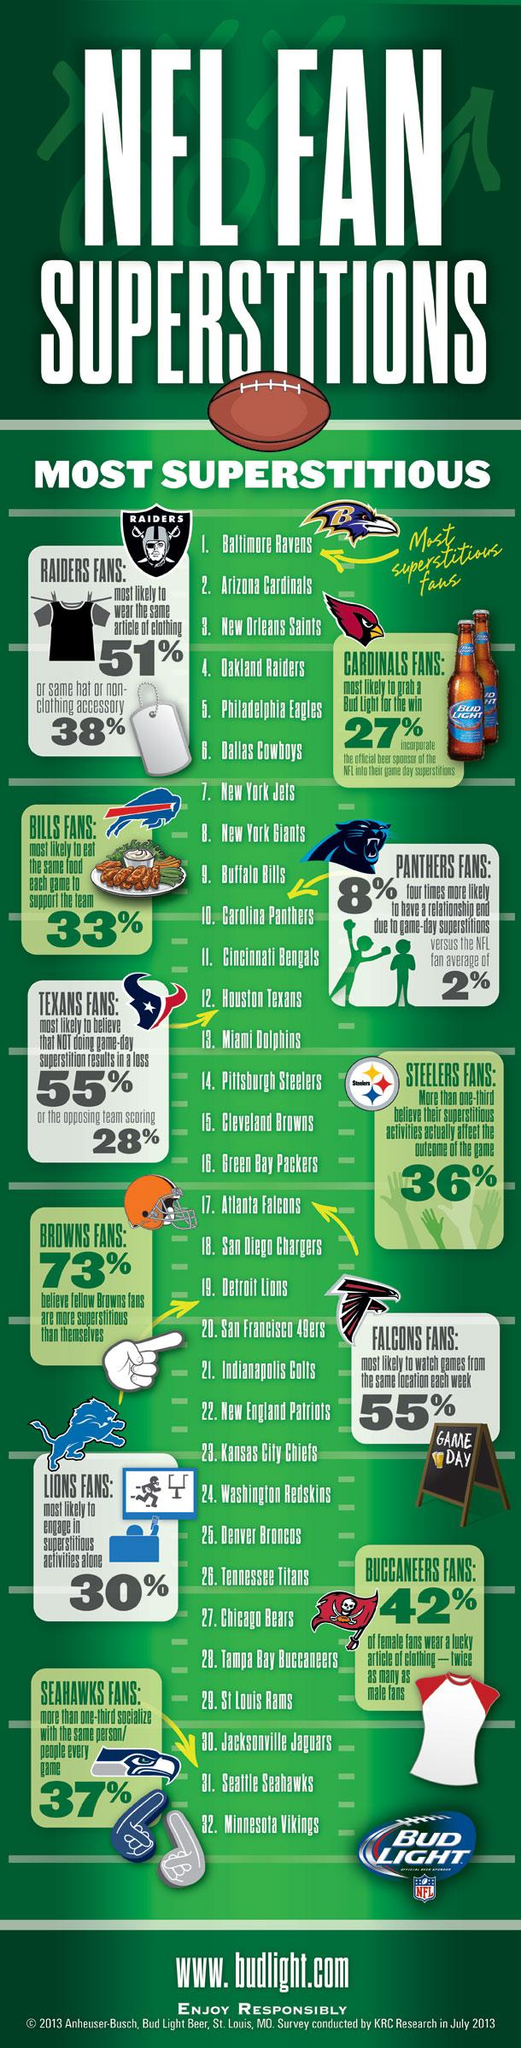Specify some key components in this picture. According to a recent survey, 30% of Detroit Lions fans are most likely to engage in superstitious activities alone. Arizona Cardinals fans are known to be the second-most superstitious among all NFL teams. A significant proportion of Buffalo Bills fans are likely to consume the same food at each game in order to demonstrate their support for the team, with 33% reporting that they do this. It is estimated that approximately 51% of Oakland Raiders fans are likely to wear the same article of clothing. The NFL team whose fans are the most superstitious is the Baltimore Ravens. 